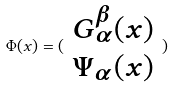<formula> <loc_0><loc_0><loc_500><loc_500>\Phi ( x ) = ( \begin{array} { c } G _ { \alpha } ^ { \beta } ( x ) \\ \Psi _ { \alpha } ( x ) \end{array} )</formula> 